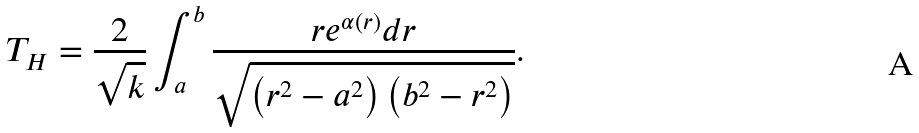Convert formula to latex. <formula><loc_0><loc_0><loc_500><loc_500>T _ { H } = \frac { 2 } { \sqrt { k } } \int _ { a } ^ { b } \frac { r e ^ { \alpha ( r ) } d r } { \sqrt { \left ( r ^ { 2 } - a ^ { 2 } \right ) \left ( b ^ { 2 } - r ^ { 2 } \right ) } } .</formula> 